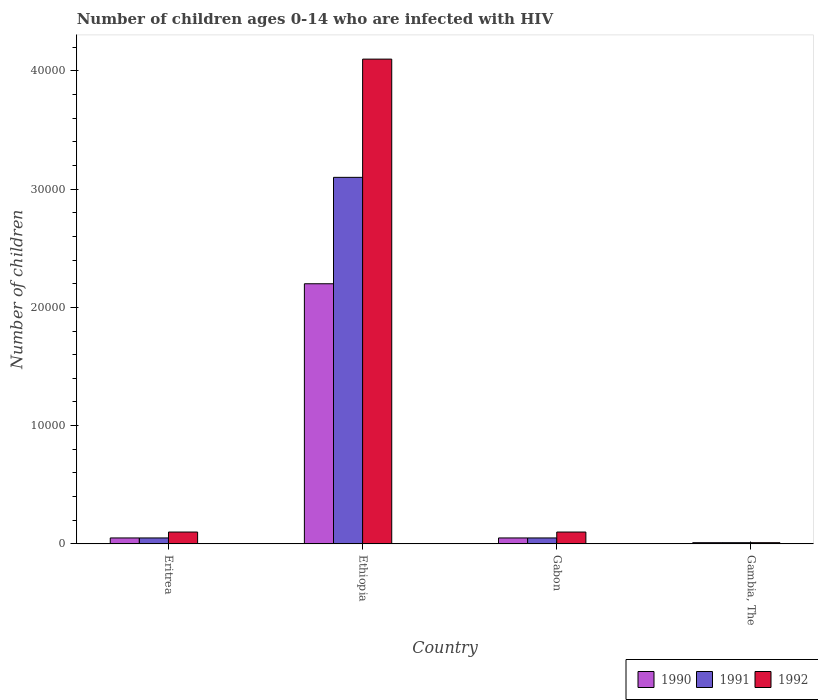Are the number of bars per tick equal to the number of legend labels?
Your answer should be compact. Yes. Are the number of bars on each tick of the X-axis equal?
Your response must be concise. Yes. How many bars are there on the 4th tick from the right?
Provide a succinct answer. 3. What is the label of the 2nd group of bars from the left?
Your response must be concise. Ethiopia. What is the number of HIV infected children in 1992 in Eritrea?
Your answer should be very brief. 1000. Across all countries, what is the maximum number of HIV infected children in 1990?
Offer a very short reply. 2.20e+04. Across all countries, what is the minimum number of HIV infected children in 1990?
Offer a very short reply. 100. In which country was the number of HIV infected children in 1990 maximum?
Your answer should be very brief. Ethiopia. In which country was the number of HIV infected children in 1991 minimum?
Your answer should be compact. Gambia, The. What is the total number of HIV infected children in 1990 in the graph?
Provide a succinct answer. 2.31e+04. What is the difference between the number of HIV infected children in 1990 in Eritrea and that in Gambia, The?
Provide a short and direct response. 400. What is the difference between the number of HIV infected children in 1991 in Gambia, The and the number of HIV infected children in 1990 in Gabon?
Provide a succinct answer. -400. What is the average number of HIV infected children in 1991 per country?
Keep it short and to the point. 8025. In how many countries, is the number of HIV infected children in 1990 greater than 16000?
Offer a terse response. 1. What is the ratio of the number of HIV infected children in 1992 in Gabon to that in Gambia, The?
Your response must be concise. 10. Is the number of HIV infected children in 1990 in Ethiopia less than that in Gambia, The?
Give a very brief answer. No. What is the difference between the highest and the lowest number of HIV infected children in 1991?
Give a very brief answer. 3.09e+04. In how many countries, is the number of HIV infected children in 1990 greater than the average number of HIV infected children in 1990 taken over all countries?
Your answer should be very brief. 1. Is the sum of the number of HIV infected children in 1992 in Eritrea and Ethiopia greater than the maximum number of HIV infected children in 1991 across all countries?
Keep it short and to the point. Yes. What does the 1st bar from the left in Gambia, The represents?
Keep it short and to the point. 1990. What does the 3rd bar from the right in Eritrea represents?
Make the answer very short. 1990. Is it the case that in every country, the sum of the number of HIV infected children in 1992 and number of HIV infected children in 1991 is greater than the number of HIV infected children in 1990?
Ensure brevity in your answer.  Yes. How many bars are there?
Make the answer very short. 12. What is the difference between two consecutive major ticks on the Y-axis?
Your response must be concise. 10000. Are the values on the major ticks of Y-axis written in scientific E-notation?
Provide a succinct answer. No. Does the graph contain any zero values?
Provide a short and direct response. No. Where does the legend appear in the graph?
Ensure brevity in your answer.  Bottom right. How are the legend labels stacked?
Make the answer very short. Horizontal. What is the title of the graph?
Offer a terse response. Number of children ages 0-14 who are infected with HIV. What is the label or title of the X-axis?
Offer a terse response. Country. What is the label or title of the Y-axis?
Offer a terse response. Number of children. What is the Number of children of 1991 in Eritrea?
Ensure brevity in your answer.  500. What is the Number of children in 1990 in Ethiopia?
Keep it short and to the point. 2.20e+04. What is the Number of children in 1991 in Ethiopia?
Your response must be concise. 3.10e+04. What is the Number of children of 1992 in Ethiopia?
Keep it short and to the point. 4.10e+04. What is the Number of children of 1990 in Gabon?
Provide a succinct answer. 500. Across all countries, what is the maximum Number of children in 1990?
Give a very brief answer. 2.20e+04. Across all countries, what is the maximum Number of children of 1991?
Your response must be concise. 3.10e+04. Across all countries, what is the maximum Number of children in 1992?
Ensure brevity in your answer.  4.10e+04. Across all countries, what is the minimum Number of children of 1990?
Provide a succinct answer. 100. Across all countries, what is the minimum Number of children of 1991?
Your response must be concise. 100. Across all countries, what is the minimum Number of children in 1992?
Ensure brevity in your answer.  100. What is the total Number of children of 1990 in the graph?
Offer a terse response. 2.31e+04. What is the total Number of children in 1991 in the graph?
Provide a succinct answer. 3.21e+04. What is the total Number of children of 1992 in the graph?
Make the answer very short. 4.31e+04. What is the difference between the Number of children of 1990 in Eritrea and that in Ethiopia?
Your response must be concise. -2.15e+04. What is the difference between the Number of children in 1991 in Eritrea and that in Ethiopia?
Provide a short and direct response. -3.05e+04. What is the difference between the Number of children in 1990 in Eritrea and that in Gabon?
Provide a short and direct response. 0. What is the difference between the Number of children in 1992 in Eritrea and that in Gambia, The?
Offer a terse response. 900. What is the difference between the Number of children in 1990 in Ethiopia and that in Gabon?
Provide a short and direct response. 2.15e+04. What is the difference between the Number of children of 1991 in Ethiopia and that in Gabon?
Offer a very short reply. 3.05e+04. What is the difference between the Number of children of 1992 in Ethiopia and that in Gabon?
Give a very brief answer. 4.00e+04. What is the difference between the Number of children of 1990 in Ethiopia and that in Gambia, The?
Make the answer very short. 2.19e+04. What is the difference between the Number of children of 1991 in Ethiopia and that in Gambia, The?
Make the answer very short. 3.09e+04. What is the difference between the Number of children of 1992 in Ethiopia and that in Gambia, The?
Offer a terse response. 4.09e+04. What is the difference between the Number of children in 1990 in Gabon and that in Gambia, The?
Give a very brief answer. 400. What is the difference between the Number of children in 1991 in Gabon and that in Gambia, The?
Offer a terse response. 400. What is the difference between the Number of children in 1992 in Gabon and that in Gambia, The?
Provide a succinct answer. 900. What is the difference between the Number of children in 1990 in Eritrea and the Number of children in 1991 in Ethiopia?
Provide a short and direct response. -3.05e+04. What is the difference between the Number of children of 1990 in Eritrea and the Number of children of 1992 in Ethiopia?
Provide a succinct answer. -4.05e+04. What is the difference between the Number of children in 1991 in Eritrea and the Number of children in 1992 in Ethiopia?
Give a very brief answer. -4.05e+04. What is the difference between the Number of children of 1990 in Eritrea and the Number of children of 1991 in Gabon?
Give a very brief answer. 0. What is the difference between the Number of children in 1990 in Eritrea and the Number of children in 1992 in Gabon?
Provide a succinct answer. -500. What is the difference between the Number of children in 1991 in Eritrea and the Number of children in 1992 in Gabon?
Offer a very short reply. -500. What is the difference between the Number of children in 1990 in Eritrea and the Number of children in 1991 in Gambia, The?
Offer a very short reply. 400. What is the difference between the Number of children of 1991 in Eritrea and the Number of children of 1992 in Gambia, The?
Your answer should be compact. 400. What is the difference between the Number of children in 1990 in Ethiopia and the Number of children in 1991 in Gabon?
Make the answer very short. 2.15e+04. What is the difference between the Number of children in 1990 in Ethiopia and the Number of children in 1992 in Gabon?
Provide a succinct answer. 2.10e+04. What is the difference between the Number of children in 1991 in Ethiopia and the Number of children in 1992 in Gabon?
Offer a terse response. 3.00e+04. What is the difference between the Number of children in 1990 in Ethiopia and the Number of children in 1991 in Gambia, The?
Your answer should be very brief. 2.19e+04. What is the difference between the Number of children of 1990 in Ethiopia and the Number of children of 1992 in Gambia, The?
Offer a very short reply. 2.19e+04. What is the difference between the Number of children in 1991 in Ethiopia and the Number of children in 1992 in Gambia, The?
Offer a terse response. 3.09e+04. What is the difference between the Number of children of 1990 in Gabon and the Number of children of 1991 in Gambia, The?
Make the answer very short. 400. What is the difference between the Number of children in 1990 in Gabon and the Number of children in 1992 in Gambia, The?
Provide a succinct answer. 400. What is the average Number of children of 1990 per country?
Provide a short and direct response. 5775. What is the average Number of children of 1991 per country?
Provide a succinct answer. 8025. What is the average Number of children in 1992 per country?
Make the answer very short. 1.08e+04. What is the difference between the Number of children in 1990 and Number of children in 1991 in Eritrea?
Provide a succinct answer. 0. What is the difference between the Number of children of 1990 and Number of children of 1992 in Eritrea?
Provide a short and direct response. -500. What is the difference between the Number of children in 1991 and Number of children in 1992 in Eritrea?
Give a very brief answer. -500. What is the difference between the Number of children of 1990 and Number of children of 1991 in Ethiopia?
Provide a succinct answer. -9000. What is the difference between the Number of children in 1990 and Number of children in 1992 in Ethiopia?
Offer a terse response. -1.90e+04. What is the difference between the Number of children of 1990 and Number of children of 1992 in Gabon?
Provide a succinct answer. -500. What is the difference between the Number of children of 1991 and Number of children of 1992 in Gabon?
Offer a terse response. -500. What is the difference between the Number of children of 1990 and Number of children of 1992 in Gambia, The?
Make the answer very short. 0. What is the ratio of the Number of children in 1990 in Eritrea to that in Ethiopia?
Your answer should be compact. 0.02. What is the ratio of the Number of children in 1991 in Eritrea to that in Ethiopia?
Make the answer very short. 0.02. What is the ratio of the Number of children in 1992 in Eritrea to that in Ethiopia?
Provide a short and direct response. 0.02. What is the ratio of the Number of children of 1990 in Eritrea to that in Gambia, The?
Keep it short and to the point. 5. What is the ratio of the Number of children of 1991 in Eritrea to that in Gambia, The?
Provide a short and direct response. 5. What is the ratio of the Number of children of 1992 in Eritrea to that in Gambia, The?
Offer a terse response. 10. What is the ratio of the Number of children in 1992 in Ethiopia to that in Gabon?
Your answer should be very brief. 41. What is the ratio of the Number of children of 1990 in Ethiopia to that in Gambia, The?
Your answer should be compact. 220. What is the ratio of the Number of children of 1991 in Ethiopia to that in Gambia, The?
Provide a succinct answer. 310. What is the ratio of the Number of children in 1992 in Ethiopia to that in Gambia, The?
Ensure brevity in your answer.  410. What is the ratio of the Number of children in 1990 in Gabon to that in Gambia, The?
Provide a succinct answer. 5. What is the ratio of the Number of children of 1992 in Gabon to that in Gambia, The?
Give a very brief answer. 10. What is the difference between the highest and the second highest Number of children of 1990?
Your answer should be very brief. 2.15e+04. What is the difference between the highest and the second highest Number of children in 1991?
Offer a terse response. 3.05e+04. What is the difference between the highest and the second highest Number of children of 1992?
Offer a very short reply. 4.00e+04. What is the difference between the highest and the lowest Number of children in 1990?
Your response must be concise. 2.19e+04. What is the difference between the highest and the lowest Number of children in 1991?
Your answer should be very brief. 3.09e+04. What is the difference between the highest and the lowest Number of children of 1992?
Provide a succinct answer. 4.09e+04. 